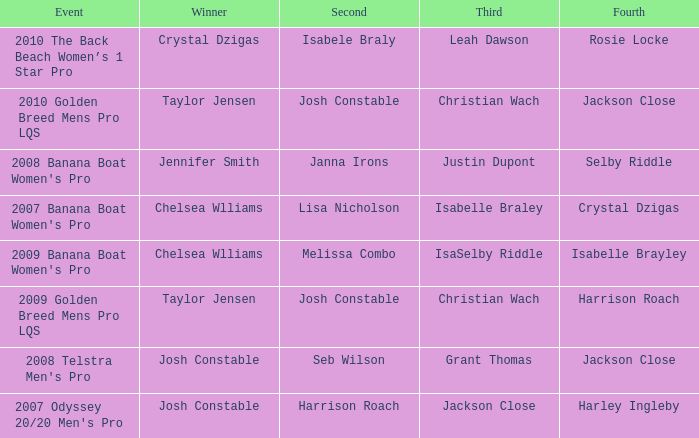Who was the Winner when Selby Riddle came in Fourth? Jennifer Smith. 